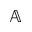<formula> <loc_0><loc_0><loc_500><loc_500>\mathbb { A }</formula> 